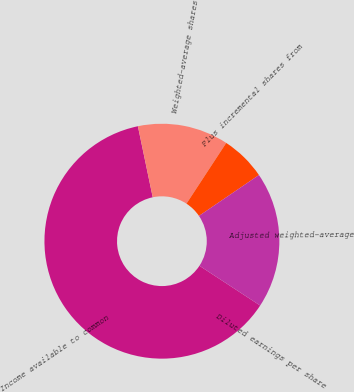<chart> <loc_0><loc_0><loc_500><loc_500><pie_chart><fcel>Income available to common<fcel>Weighted-average shares<fcel>Plus incremental shares from<fcel>Adjusted weighted-average<fcel>Diluted earnings per share<nl><fcel>62.5%<fcel>12.5%<fcel>6.25%<fcel>18.75%<fcel>0.0%<nl></chart> 